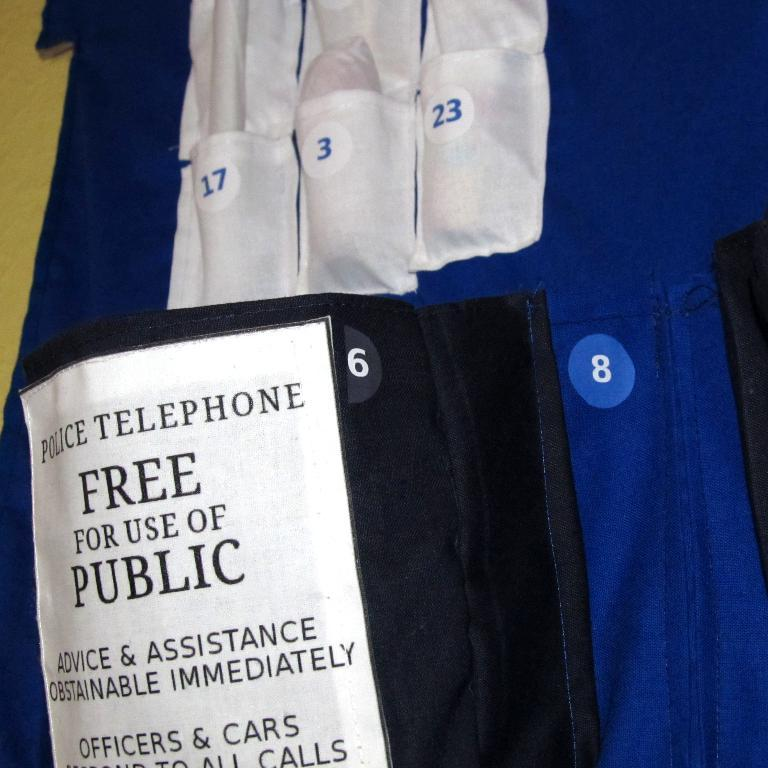<image>
Present a compact description of the photo's key features. a sign that says free for public use 